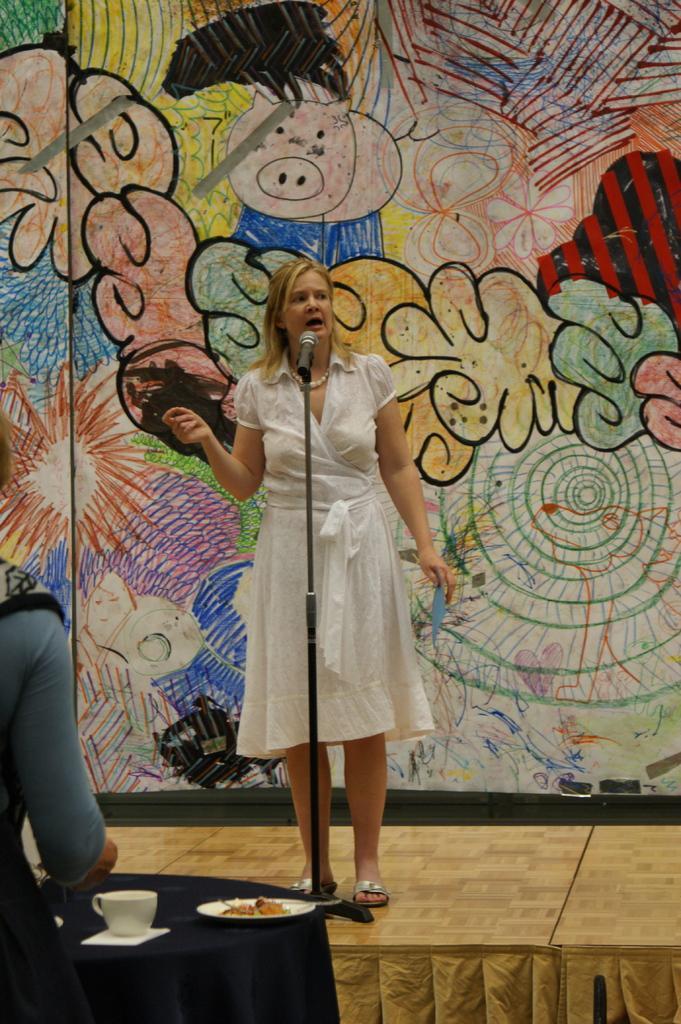Please provide a concise description of this image. In the center of the image we can see a lady is standing on the stage and talking and wearing a white dress and holding an object. In-front of her we can see a mic with stand. At the bottom of the image we can see the stage, cloth, table which is covered with cloth and a person is bending. On the table we can see a cup, plate which contains food. In the background of the image we can see the painting on the wall. 